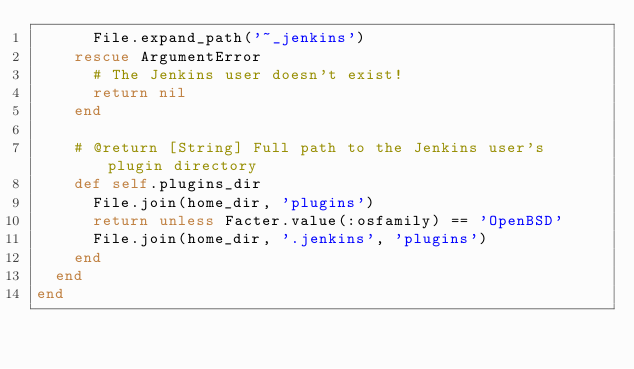Convert code to text. <code><loc_0><loc_0><loc_500><loc_500><_Ruby_>      File.expand_path('~_jenkins')
    rescue ArgumentError
      # The Jenkins user doesn't exist!
      return nil
    end

    # @return [String] Full path to the Jenkins user's plugin directory
    def self.plugins_dir
      File.join(home_dir, 'plugins')
      return unless Facter.value(:osfamily) == 'OpenBSD'
      File.join(home_dir, '.jenkins', 'plugins')
    end
  end
end
</code> 